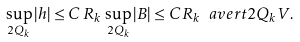Convert formula to latex. <formula><loc_0><loc_0><loc_500><loc_500>\sup _ { 2 Q _ { k } } | h | \leq C \, R _ { k } \, \sup _ { 2 Q _ { k } } | B | \leq C R _ { k } \ a v e r t { 2 Q _ { k } } V .</formula> 